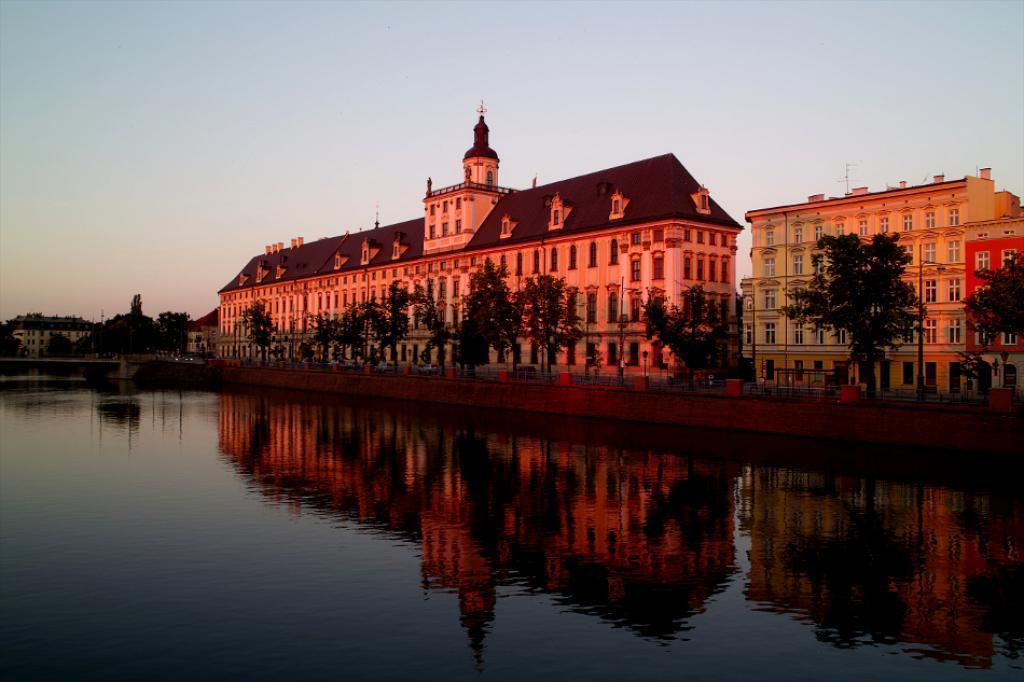Describe this image in one or two sentences. In the center of the image we can see the buildings, windows, trees, poles, fencing. At the top of the image we can see the sky. At the bottom of the image we can see the water. 